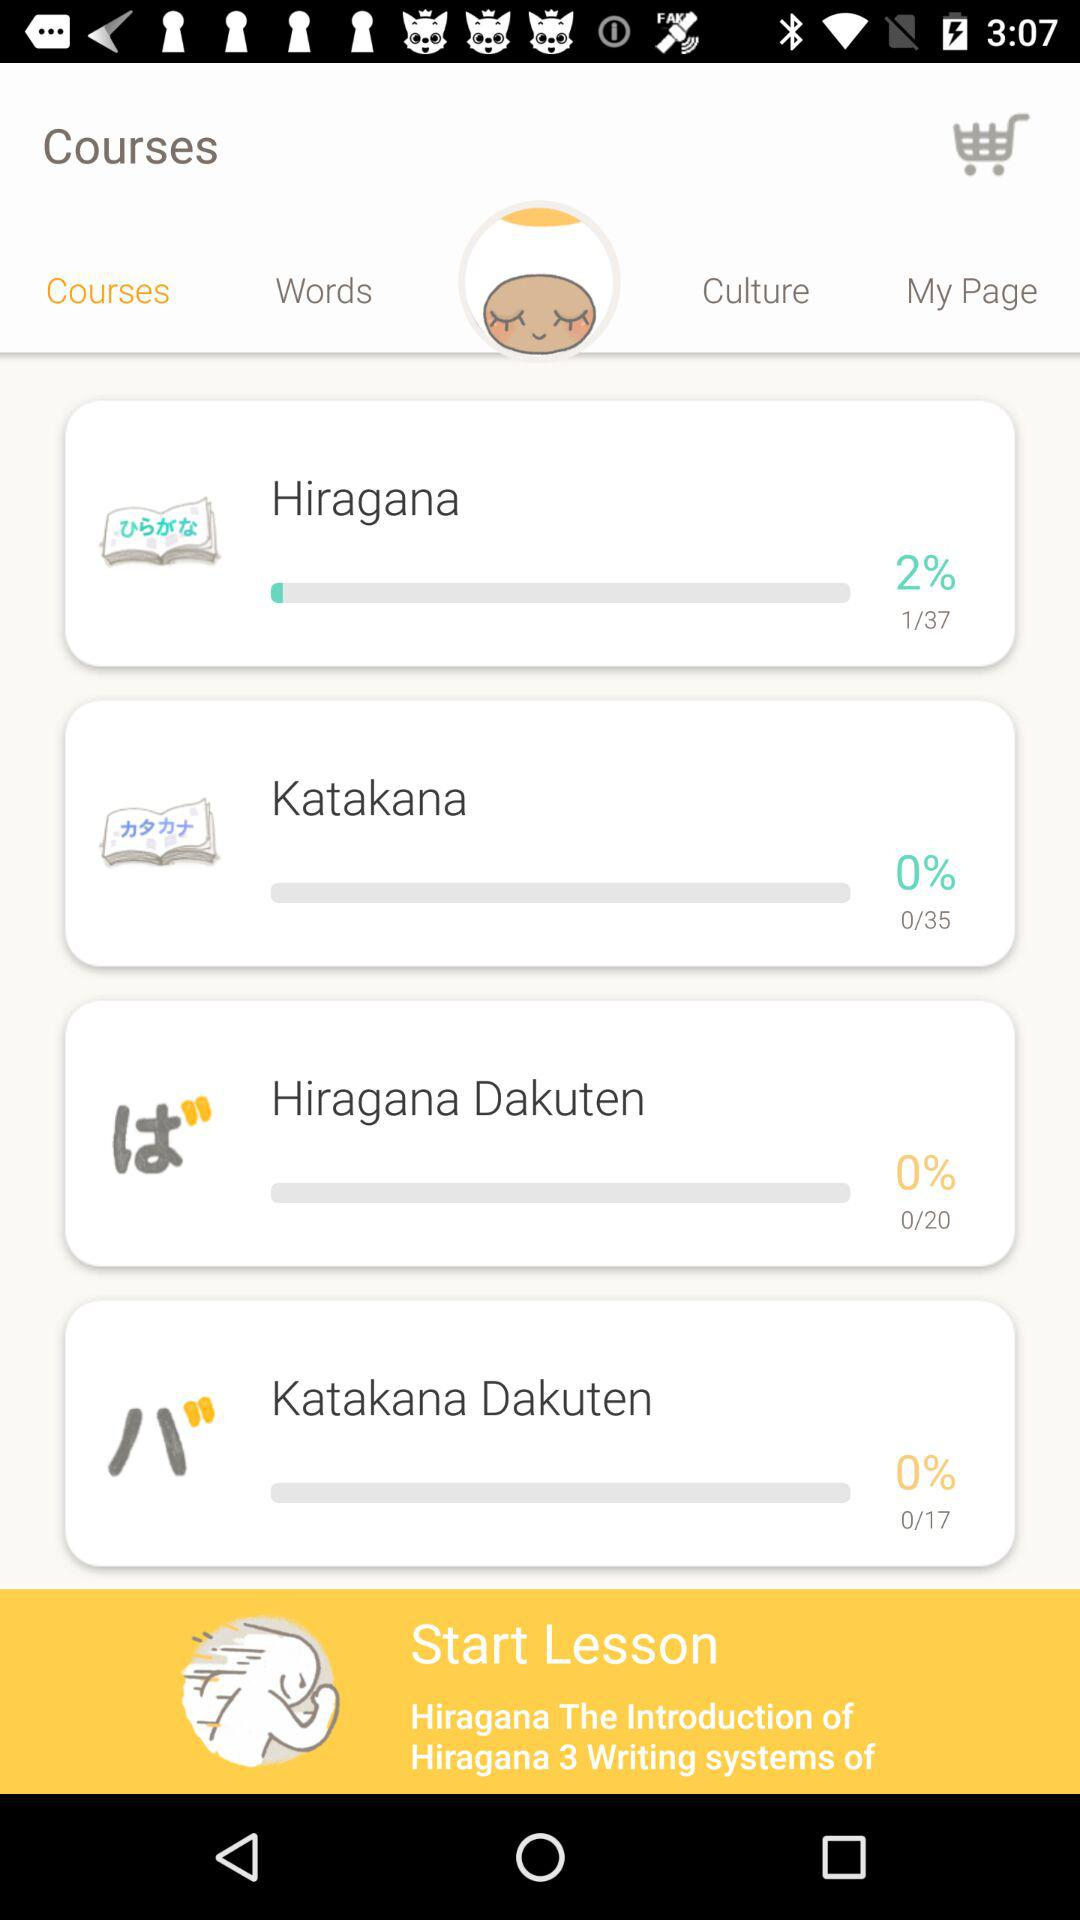Which tab is selected? The selected tab is "Courses". 